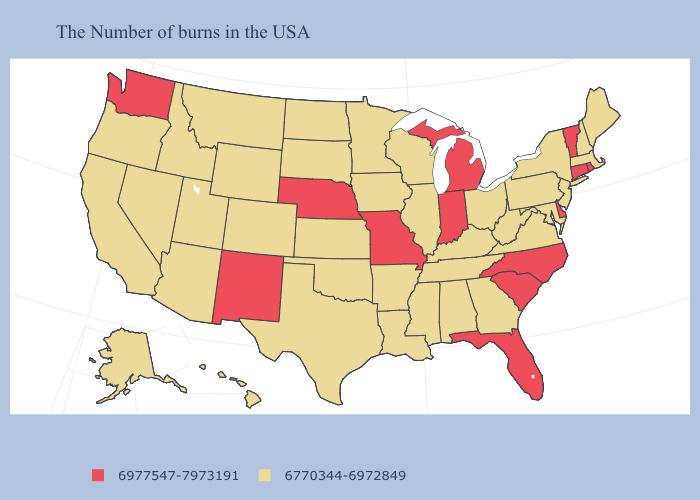What is the highest value in states that border Delaware?
Concise answer only. 6770344-6972849. Name the states that have a value in the range 6977547-7973191?
Concise answer only. Rhode Island, Vermont, Connecticut, Delaware, North Carolina, South Carolina, Florida, Michigan, Indiana, Missouri, Nebraska, New Mexico, Washington. Does Delaware have a lower value than Minnesota?
Answer briefly. No. Which states hav the highest value in the Northeast?
Give a very brief answer. Rhode Island, Vermont, Connecticut. Name the states that have a value in the range 6977547-7973191?
Be succinct. Rhode Island, Vermont, Connecticut, Delaware, North Carolina, South Carolina, Florida, Michigan, Indiana, Missouri, Nebraska, New Mexico, Washington. Does South Dakota have the lowest value in the USA?
Give a very brief answer. Yes. Among the states that border Massachusetts , does New York have the lowest value?
Short answer required. Yes. What is the value of Massachusetts?
Give a very brief answer. 6770344-6972849. Among the states that border Illinois , which have the lowest value?
Short answer required. Kentucky, Wisconsin, Iowa. Name the states that have a value in the range 6770344-6972849?
Write a very short answer. Maine, Massachusetts, New Hampshire, New York, New Jersey, Maryland, Pennsylvania, Virginia, West Virginia, Ohio, Georgia, Kentucky, Alabama, Tennessee, Wisconsin, Illinois, Mississippi, Louisiana, Arkansas, Minnesota, Iowa, Kansas, Oklahoma, Texas, South Dakota, North Dakota, Wyoming, Colorado, Utah, Montana, Arizona, Idaho, Nevada, California, Oregon, Alaska, Hawaii. Does New Mexico have the same value as Massachusetts?
Answer briefly. No. Among the states that border Rhode Island , does Massachusetts have the highest value?
Be succinct. No. Among the states that border Tennessee , which have the highest value?
Keep it brief. North Carolina, Missouri. Name the states that have a value in the range 6977547-7973191?
Give a very brief answer. Rhode Island, Vermont, Connecticut, Delaware, North Carolina, South Carolina, Florida, Michigan, Indiana, Missouri, Nebraska, New Mexico, Washington. 